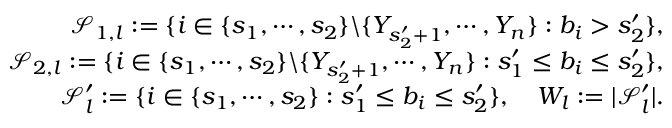Convert formula to latex. <formula><loc_0><loc_0><loc_500><loc_500>\begin{array} { r l r } & { \mathcal { S } _ { 1 , l } \colon = \{ i \in \{ s _ { 1 } , \cdots , s _ { 2 } \} \ \{ Y _ { s _ { 2 } ^ { \prime } + 1 } , \cdots , Y _ { n } \} \colon b _ { i } > s _ { 2 } ^ { \prime } \} , } \\ & { \mathcal { S } _ { 2 , l } \colon = \{ i \in \{ s _ { 1 } , \cdots , s _ { 2 } \} \ \{ Y _ { s _ { 2 } ^ { \prime } + 1 } , \cdots , Y _ { n } \} \colon s _ { 1 } ^ { \prime } \leq b _ { i } \leq s _ { 2 } ^ { \prime } \} , } \\ & { \mathcal { S } _ { l } ^ { \prime } \colon = \{ i \in \{ s _ { 1 } , \cdots , s _ { 2 } \} \colon s _ { 1 } ^ { \prime } \leq b _ { i } \leq s _ { 2 } ^ { \prime } \} , \quad W _ { l } \colon = | \mathcal { S } _ { l } ^ { \prime } | . } \end{array}</formula> 